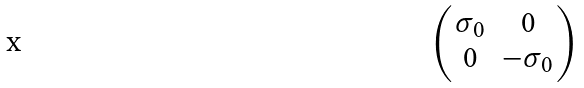<formula> <loc_0><loc_0><loc_500><loc_500>\begin{pmatrix} \sigma _ { 0 } & 0 \\ 0 & - \sigma _ { 0 } \end{pmatrix}</formula> 